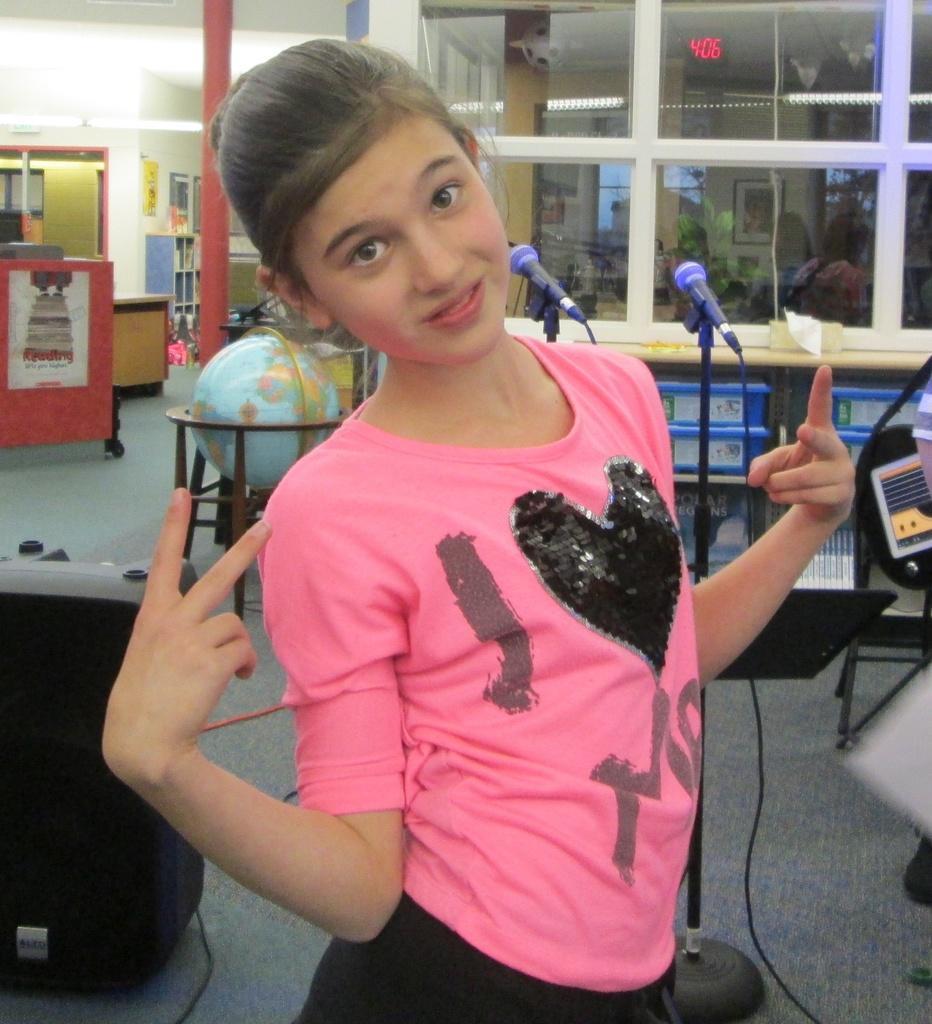Please provide a concise description of this image. In this image we can see a girl wearing pink color T-shirt, behind her there are tables, mics, globe on the stand, electronic instruments, walls, lights, and we can see glass windows chairs, and some posters on the wall. 